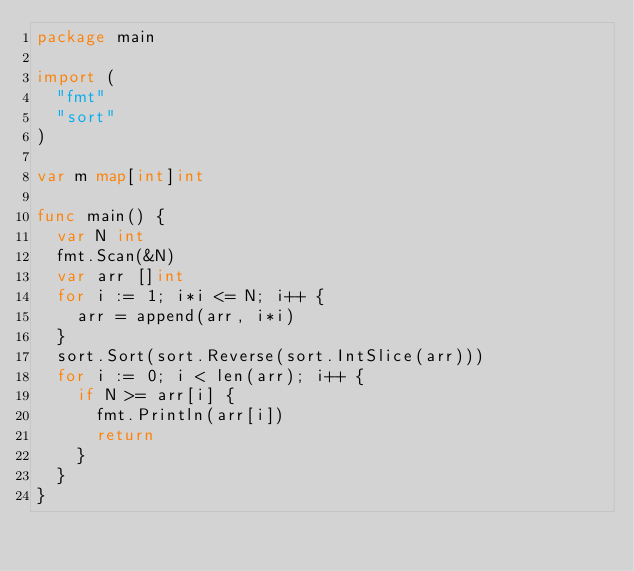Convert code to text. <code><loc_0><loc_0><loc_500><loc_500><_Go_>package main

import (
	"fmt"
	"sort"
)

var m map[int]int

func main() {
	var N int
	fmt.Scan(&N)
	var arr []int
	for i := 1; i*i <= N; i++ {
		arr = append(arr, i*i)
	}
	sort.Sort(sort.Reverse(sort.IntSlice(arr)))
	for i := 0; i < len(arr); i++ {
		if N >= arr[i] {
			fmt.Println(arr[i])
			return
		}
	}
}</code> 